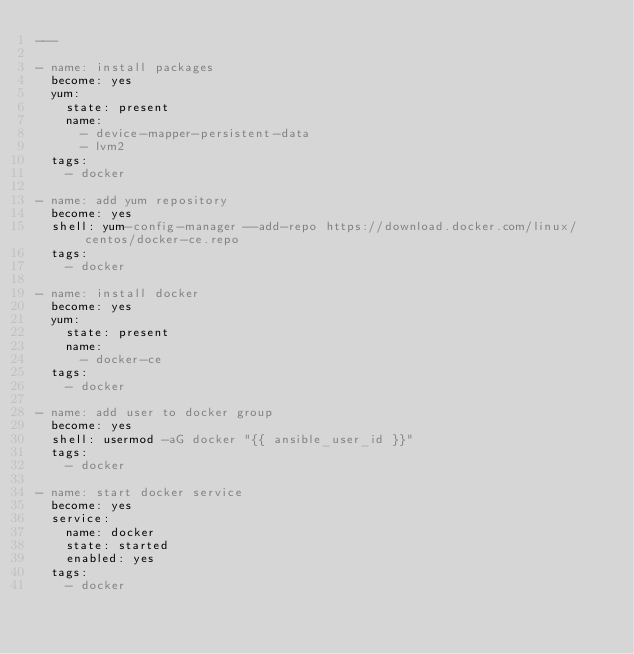<code> <loc_0><loc_0><loc_500><loc_500><_YAML_>---

- name: install packages
  become: yes
  yum:
    state: present
    name:
      - device-mapper-persistent-data
      - lvm2
  tags:
    - docker

- name: add yum repository
  become: yes
  shell: yum-config-manager --add-repo https://download.docker.com/linux/centos/docker-ce.repo
  tags:
    - docker

- name: install docker
  become: yes
  yum:
    state: present
    name:
      - docker-ce
  tags:
    - docker

- name: add user to docker group
  become: yes
  shell: usermod -aG docker "{{ ansible_user_id }}"
  tags:
    - docker

- name: start docker service
  become: yes
  service:
    name: docker
    state: started
    enabled: yes
  tags:
    - docker
</code> 